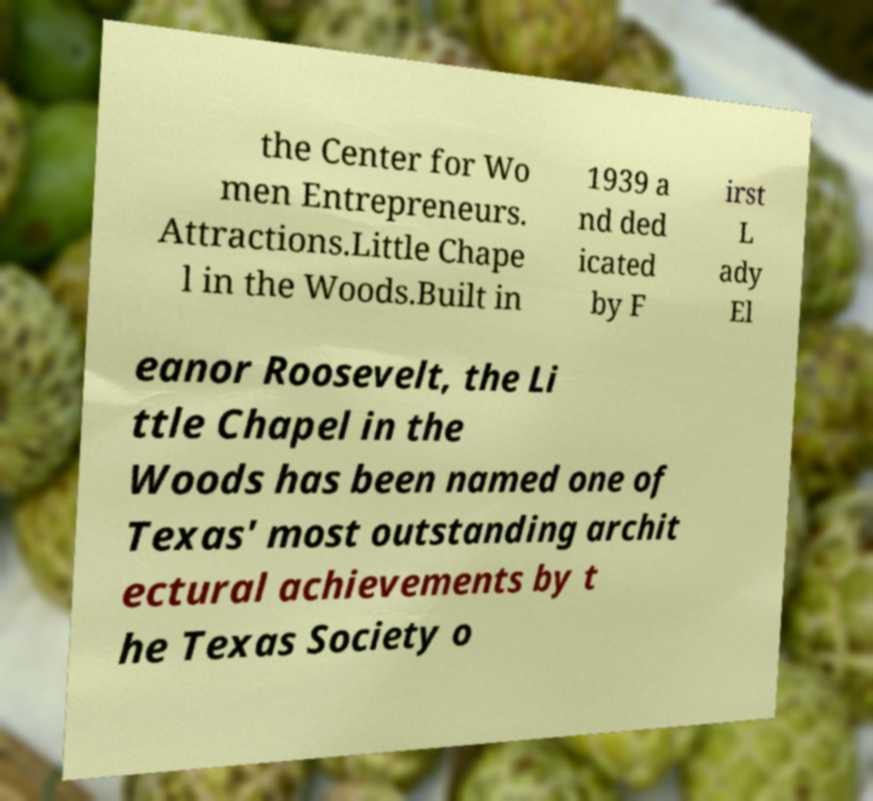Can you read and provide the text displayed in the image?This photo seems to have some interesting text. Can you extract and type it out for me? the Center for Wo men Entrepreneurs. Attractions.Little Chape l in the Woods.Built in 1939 a nd ded icated by F irst L ady El eanor Roosevelt, the Li ttle Chapel in the Woods has been named one of Texas' most outstanding archit ectural achievements by t he Texas Society o 